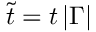Convert formula to latex. <formula><loc_0><loc_0><loc_500><loc_500>\tilde { t } = t \, | \Gamma |</formula> 